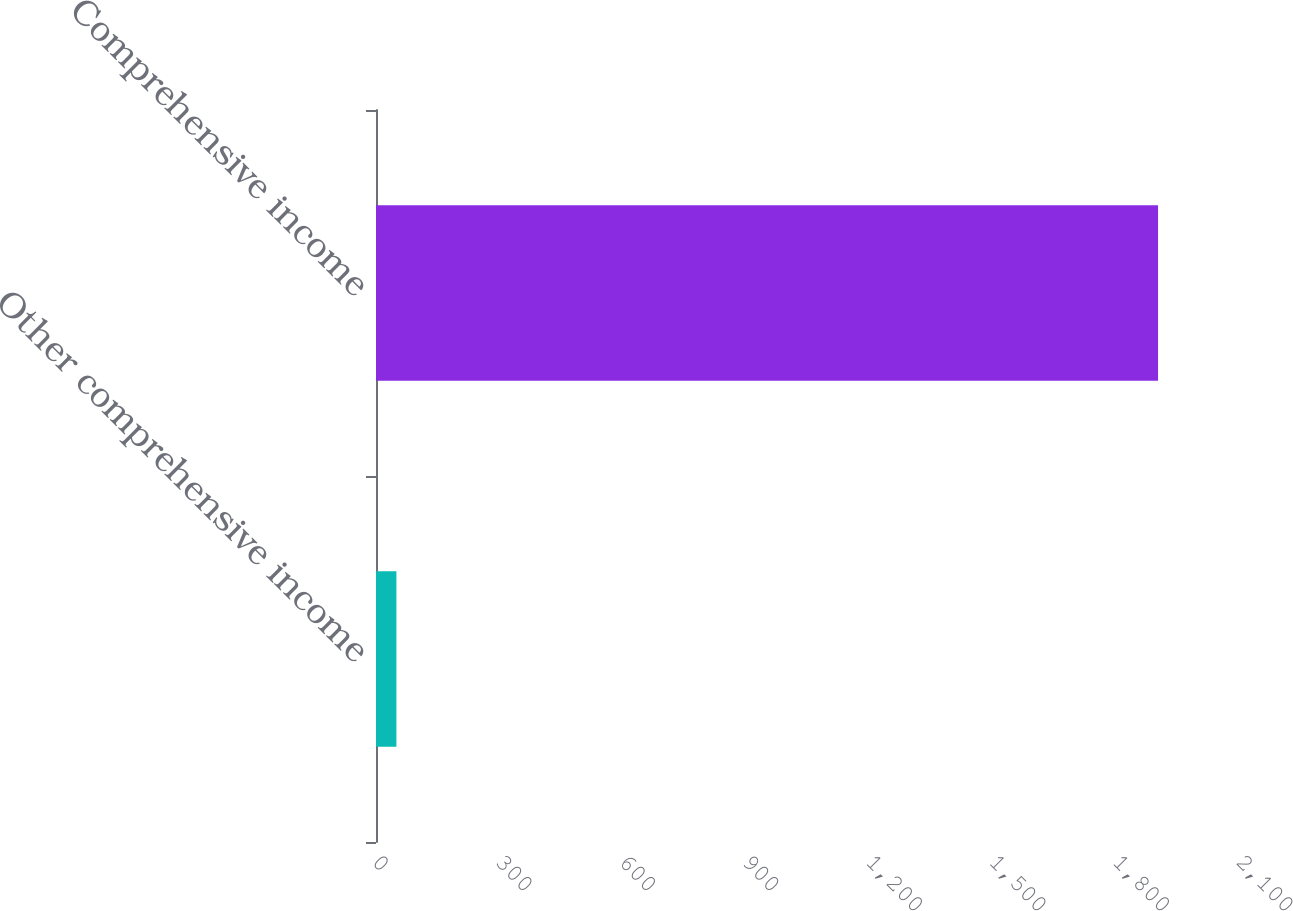<chart> <loc_0><loc_0><loc_500><loc_500><bar_chart><fcel>Other comprehensive income<fcel>Comprehensive income<nl><fcel>49.6<fcel>1900.8<nl></chart> 